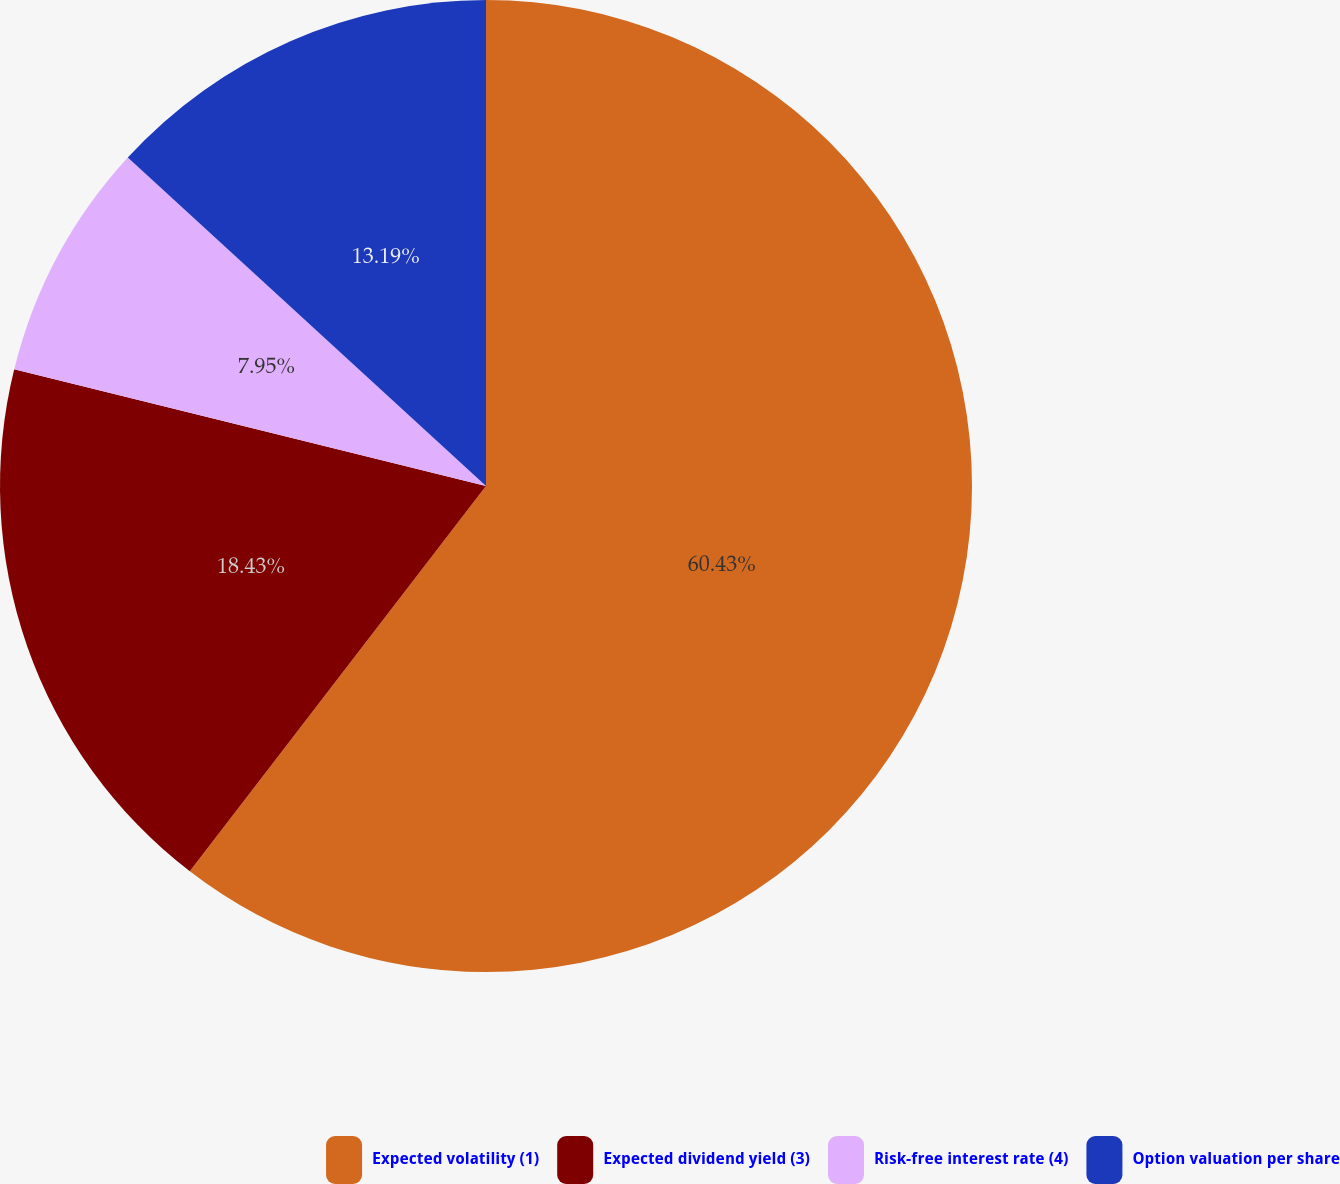Convert chart to OTSL. <chart><loc_0><loc_0><loc_500><loc_500><pie_chart><fcel>Expected volatility (1)<fcel>Expected dividend yield (3)<fcel>Risk-free interest rate (4)<fcel>Option valuation per share<nl><fcel>60.43%<fcel>18.43%<fcel>7.95%<fcel>13.19%<nl></chart> 